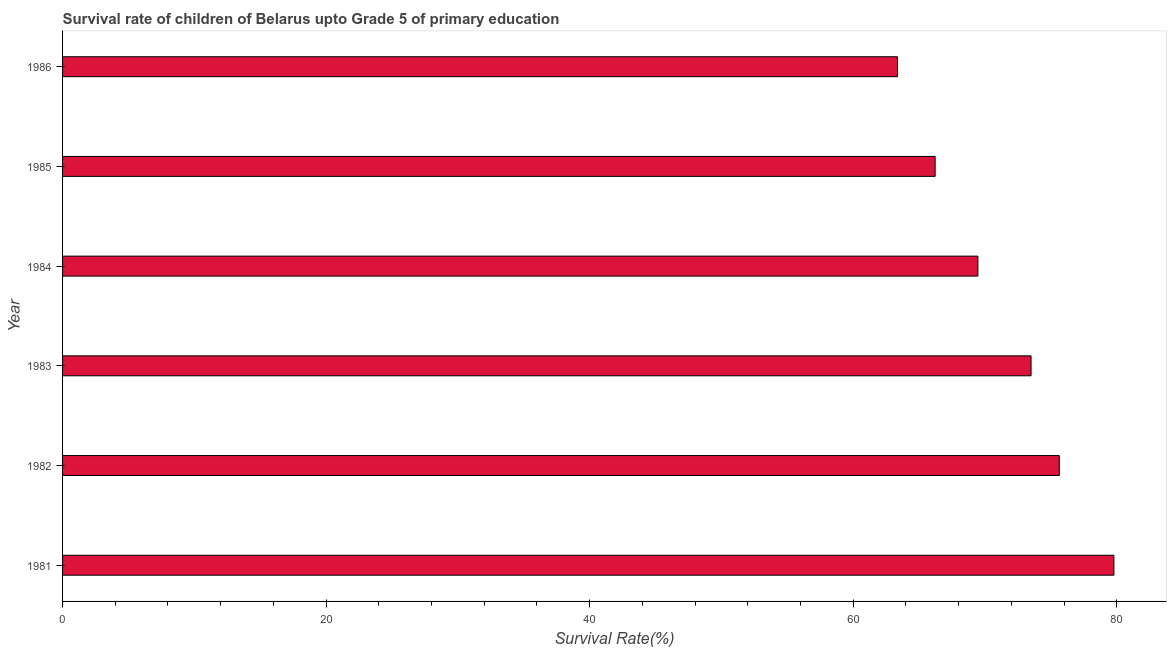Does the graph contain grids?
Offer a terse response. No. What is the title of the graph?
Keep it short and to the point. Survival rate of children of Belarus upto Grade 5 of primary education. What is the label or title of the X-axis?
Offer a very short reply. Survival Rate(%). What is the label or title of the Y-axis?
Give a very brief answer. Year. What is the survival rate in 1985?
Provide a succinct answer. 66.22. Across all years, what is the maximum survival rate?
Your answer should be very brief. 79.78. Across all years, what is the minimum survival rate?
Make the answer very short. 63.36. In which year was the survival rate minimum?
Offer a very short reply. 1986. What is the sum of the survival rate?
Provide a short and direct response. 427.95. What is the difference between the survival rate in 1982 and 1983?
Provide a short and direct response. 2.14. What is the average survival rate per year?
Your answer should be very brief. 71.33. What is the median survival rate?
Provide a short and direct response. 71.48. Do a majority of the years between 1984 and 1985 (inclusive) have survival rate greater than 72 %?
Offer a terse response. No. What is the ratio of the survival rate in 1981 to that in 1984?
Make the answer very short. 1.15. What is the difference between the highest and the second highest survival rate?
Offer a very short reply. 4.14. Is the sum of the survival rate in 1982 and 1985 greater than the maximum survival rate across all years?
Offer a terse response. Yes. What is the difference between the highest and the lowest survival rate?
Your answer should be compact. 16.42. Are all the bars in the graph horizontal?
Your response must be concise. Yes. Are the values on the major ticks of X-axis written in scientific E-notation?
Your response must be concise. No. What is the Survival Rate(%) of 1981?
Provide a short and direct response. 79.78. What is the Survival Rate(%) in 1982?
Ensure brevity in your answer.  75.64. What is the Survival Rate(%) in 1983?
Provide a succinct answer. 73.49. What is the Survival Rate(%) in 1984?
Provide a short and direct response. 69.46. What is the Survival Rate(%) of 1985?
Give a very brief answer. 66.22. What is the Survival Rate(%) of 1986?
Offer a very short reply. 63.36. What is the difference between the Survival Rate(%) in 1981 and 1982?
Provide a succinct answer. 4.15. What is the difference between the Survival Rate(%) in 1981 and 1983?
Give a very brief answer. 6.29. What is the difference between the Survival Rate(%) in 1981 and 1984?
Your answer should be compact. 10.32. What is the difference between the Survival Rate(%) in 1981 and 1985?
Provide a succinct answer. 13.57. What is the difference between the Survival Rate(%) in 1981 and 1986?
Make the answer very short. 16.42. What is the difference between the Survival Rate(%) in 1982 and 1983?
Offer a terse response. 2.14. What is the difference between the Survival Rate(%) in 1982 and 1984?
Offer a terse response. 6.18. What is the difference between the Survival Rate(%) in 1982 and 1985?
Your answer should be very brief. 9.42. What is the difference between the Survival Rate(%) in 1982 and 1986?
Your response must be concise. 12.28. What is the difference between the Survival Rate(%) in 1983 and 1984?
Make the answer very short. 4.03. What is the difference between the Survival Rate(%) in 1983 and 1985?
Make the answer very short. 7.28. What is the difference between the Survival Rate(%) in 1983 and 1986?
Your answer should be very brief. 10.14. What is the difference between the Survival Rate(%) in 1984 and 1985?
Your response must be concise. 3.25. What is the difference between the Survival Rate(%) in 1984 and 1986?
Make the answer very short. 6.1. What is the difference between the Survival Rate(%) in 1985 and 1986?
Keep it short and to the point. 2.86. What is the ratio of the Survival Rate(%) in 1981 to that in 1982?
Offer a very short reply. 1.05. What is the ratio of the Survival Rate(%) in 1981 to that in 1983?
Give a very brief answer. 1.09. What is the ratio of the Survival Rate(%) in 1981 to that in 1984?
Keep it short and to the point. 1.15. What is the ratio of the Survival Rate(%) in 1981 to that in 1985?
Your answer should be very brief. 1.21. What is the ratio of the Survival Rate(%) in 1981 to that in 1986?
Keep it short and to the point. 1.26. What is the ratio of the Survival Rate(%) in 1982 to that in 1983?
Offer a terse response. 1.03. What is the ratio of the Survival Rate(%) in 1982 to that in 1984?
Make the answer very short. 1.09. What is the ratio of the Survival Rate(%) in 1982 to that in 1985?
Offer a terse response. 1.14. What is the ratio of the Survival Rate(%) in 1982 to that in 1986?
Make the answer very short. 1.19. What is the ratio of the Survival Rate(%) in 1983 to that in 1984?
Your answer should be compact. 1.06. What is the ratio of the Survival Rate(%) in 1983 to that in 1985?
Offer a very short reply. 1.11. What is the ratio of the Survival Rate(%) in 1983 to that in 1986?
Your answer should be compact. 1.16. What is the ratio of the Survival Rate(%) in 1984 to that in 1985?
Provide a succinct answer. 1.05. What is the ratio of the Survival Rate(%) in 1984 to that in 1986?
Provide a short and direct response. 1.1. What is the ratio of the Survival Rate(%) in 1985 to that in 1986?
Keep it short and to the point. 1.04. 